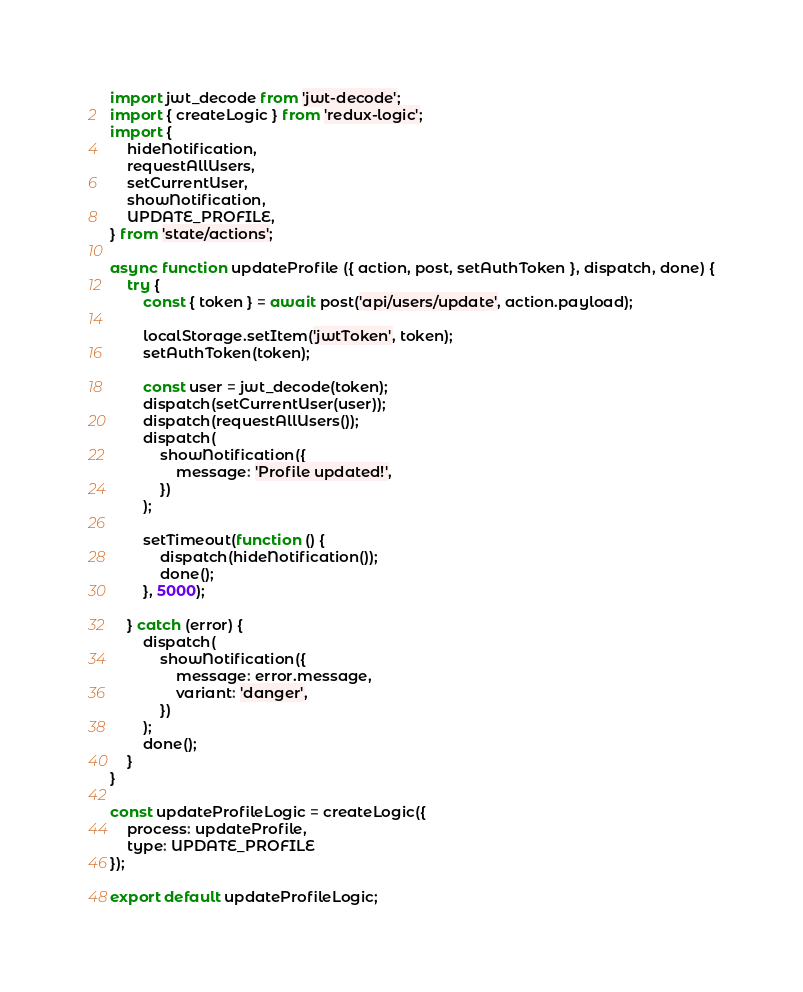Convert code to text. <code><loc_0><loc_0><loc_500><loc_500><_JavaScript_>import jwt_decode from 'jwt-decode';
import { createLogic } from 'redux-logic';
import {
    hideNotification,
    requestAllUsers,
    setCurrentUser,
    showNotification,
    UPDATE_PROFILE,
} from 'state/actions';

async function updateProfile ({ action, post, setAuthToken }, dispatch, done) {
    try {
        const { token } = await post('api/users/update', action.payload);

        localStorage.setItem('jwtToken', token);
        setAuthToken(token);

        const user = jwt_decode(token);
        dispatch(setCurrentUser(user));
        dispatch(requestAllUsers());
        dispatch(
            showNotification({
                message: 'Profile updated!',
            })
        );

        setTimeout(function () {
            dispatch(hideNotification());
            done();
        }, 5000);

    } catch (error) {
        dispatch(
            showNotification({
                message: error.message,
                variant: 'danger',
            })
        );
        done();
    }
}

const updateProfileLogic = createLogic({
    process: updateProfile,
    type: UPDATE_PROFILE
});

export default updateProfileLogic;
</code> 